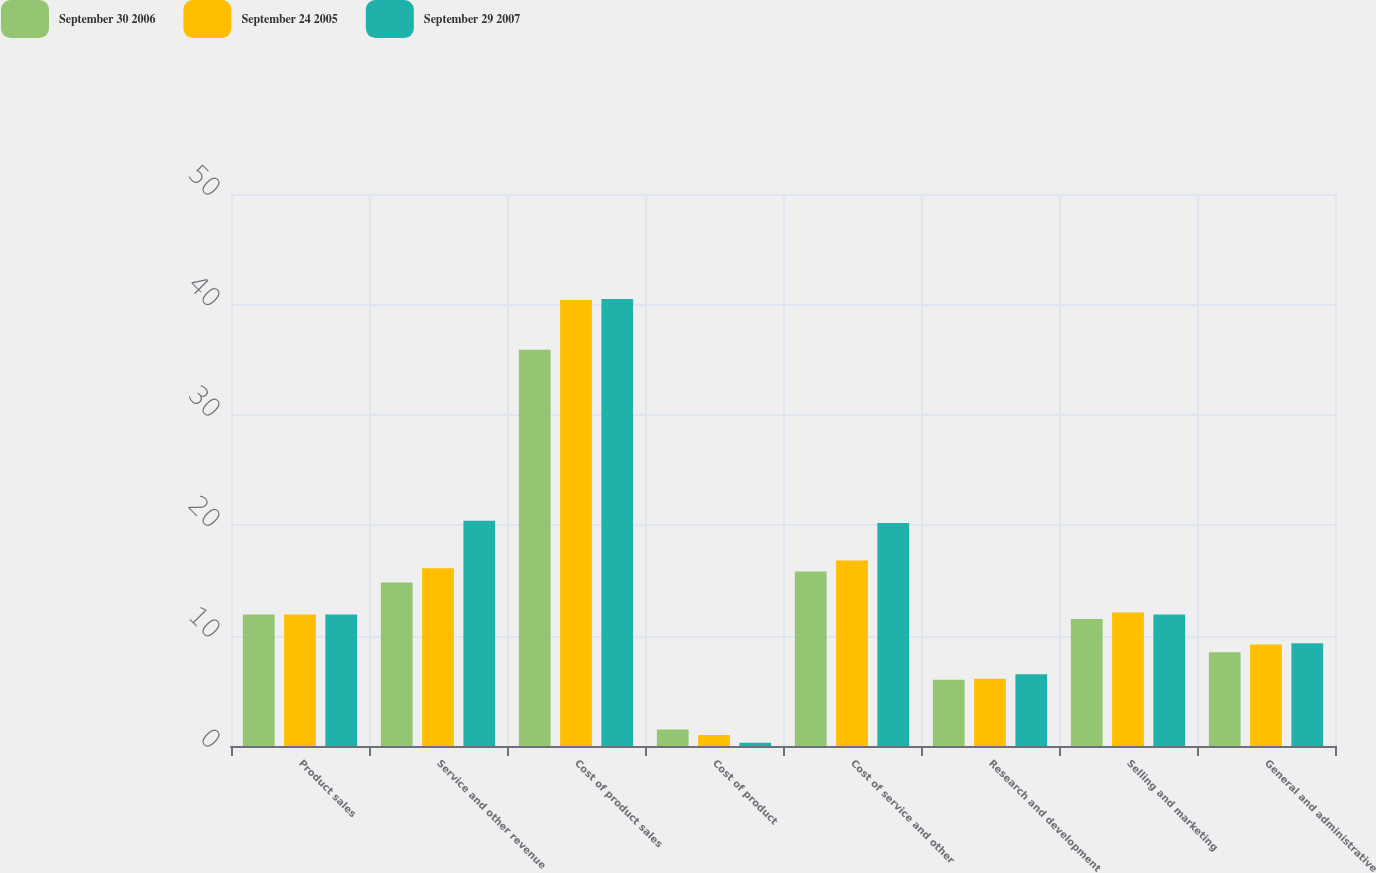Convert chart to OTSL. <chart><loc_0><loc_0><loc_500><loc_500><stacked_bar_chart><ecel><fcel>Product sales<fcel>Service and other revenue<fcel>Cost of product sales<fcel>Cost of product<fcel>Cost of service and other<fcel>Research and development<fcel>Selling and marketing<fcel>General and administrative<nl><fcel>September 30 2006<fcel>11.9<fcel>14.8<fcel>35.9<fcel>1.5<fcel>15.8<fcel>6<fcel>11.5<fcel>8.5<nl><fcel>September 24 2005<fcel>11.9<fcel>16.1<fcel>40.4<fcel>1<fcel>16.8<fcel>6.1<fcel>12.1<fcel>9.2<nl><fcel>September 29 2007<fcel>11.9<fcel>20.4<fcel>40.5<fcel>0.3<fcel>20.2<fcel>6.5<fcel>11.9<fcel>9.3<nl></chart> 